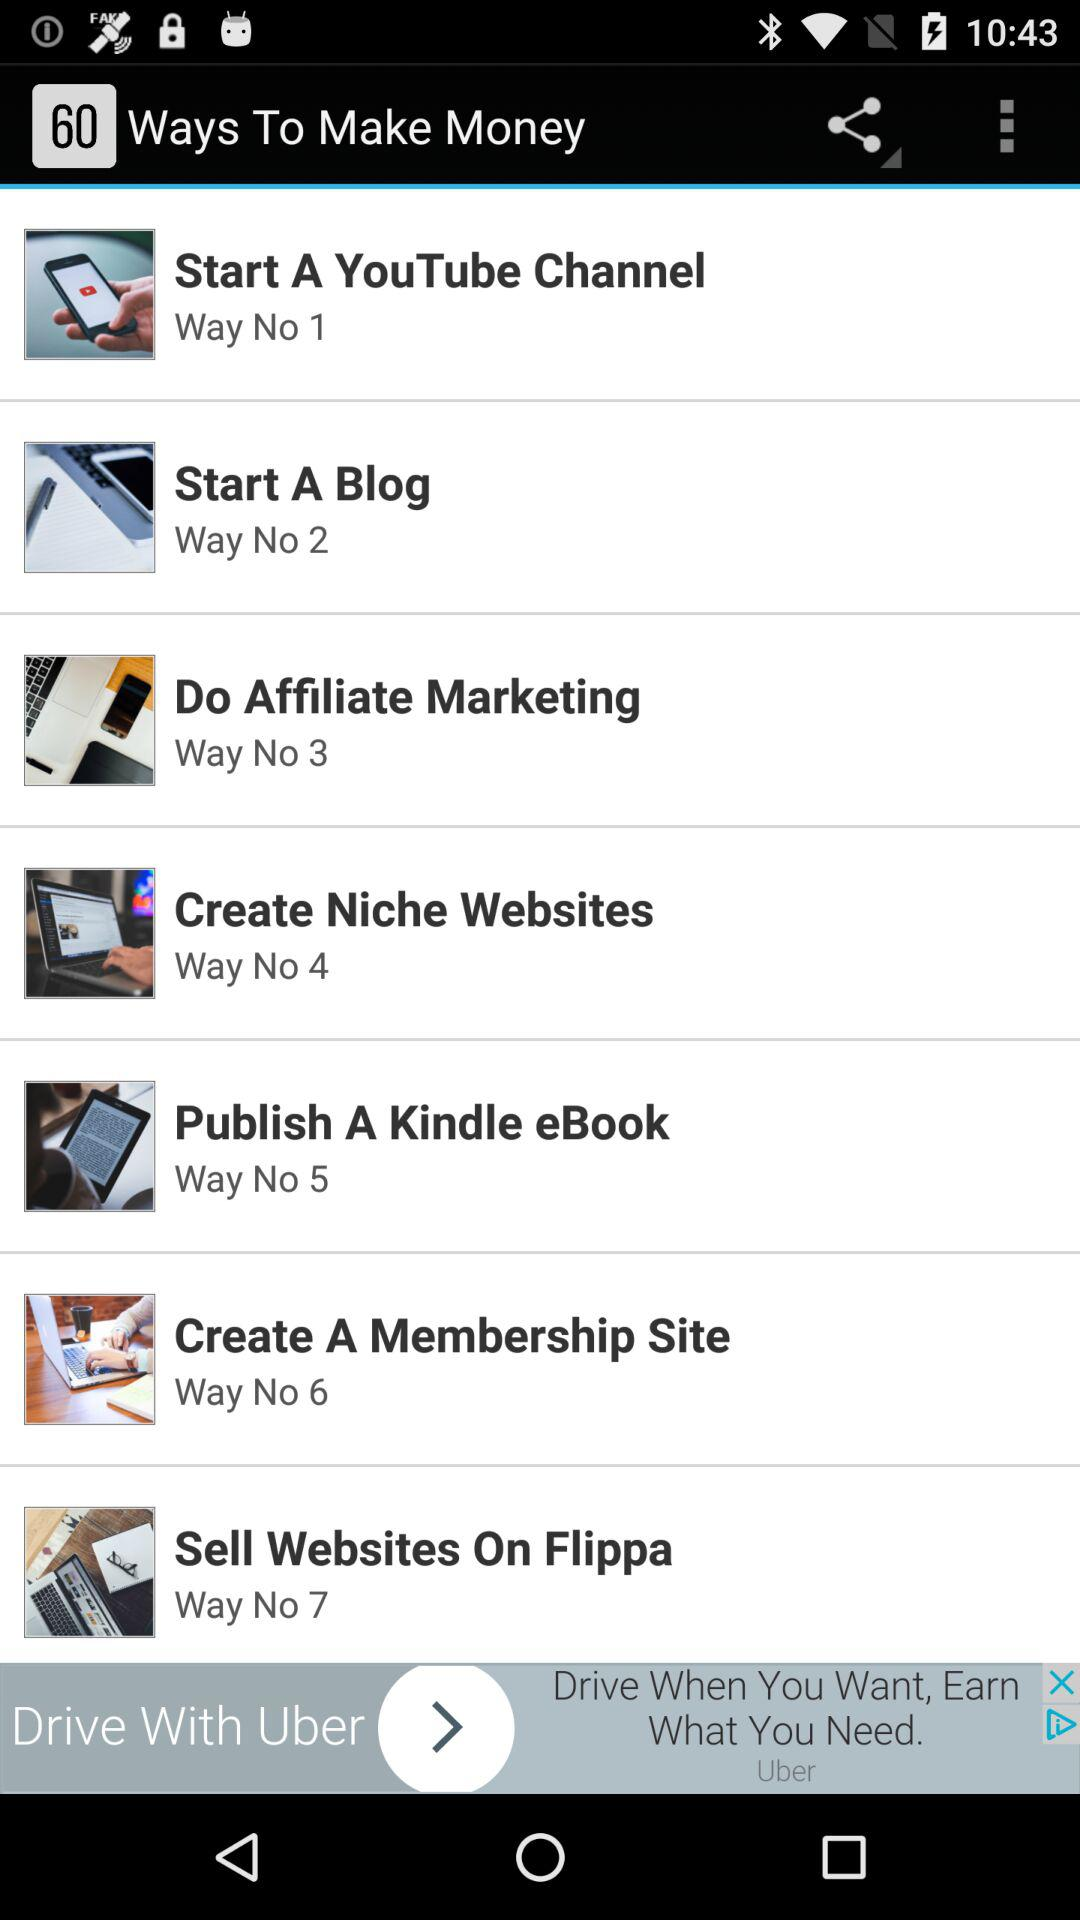Who is this application powered by?
When the provided information is insufficient, respond with <no answer>. <no answer> 